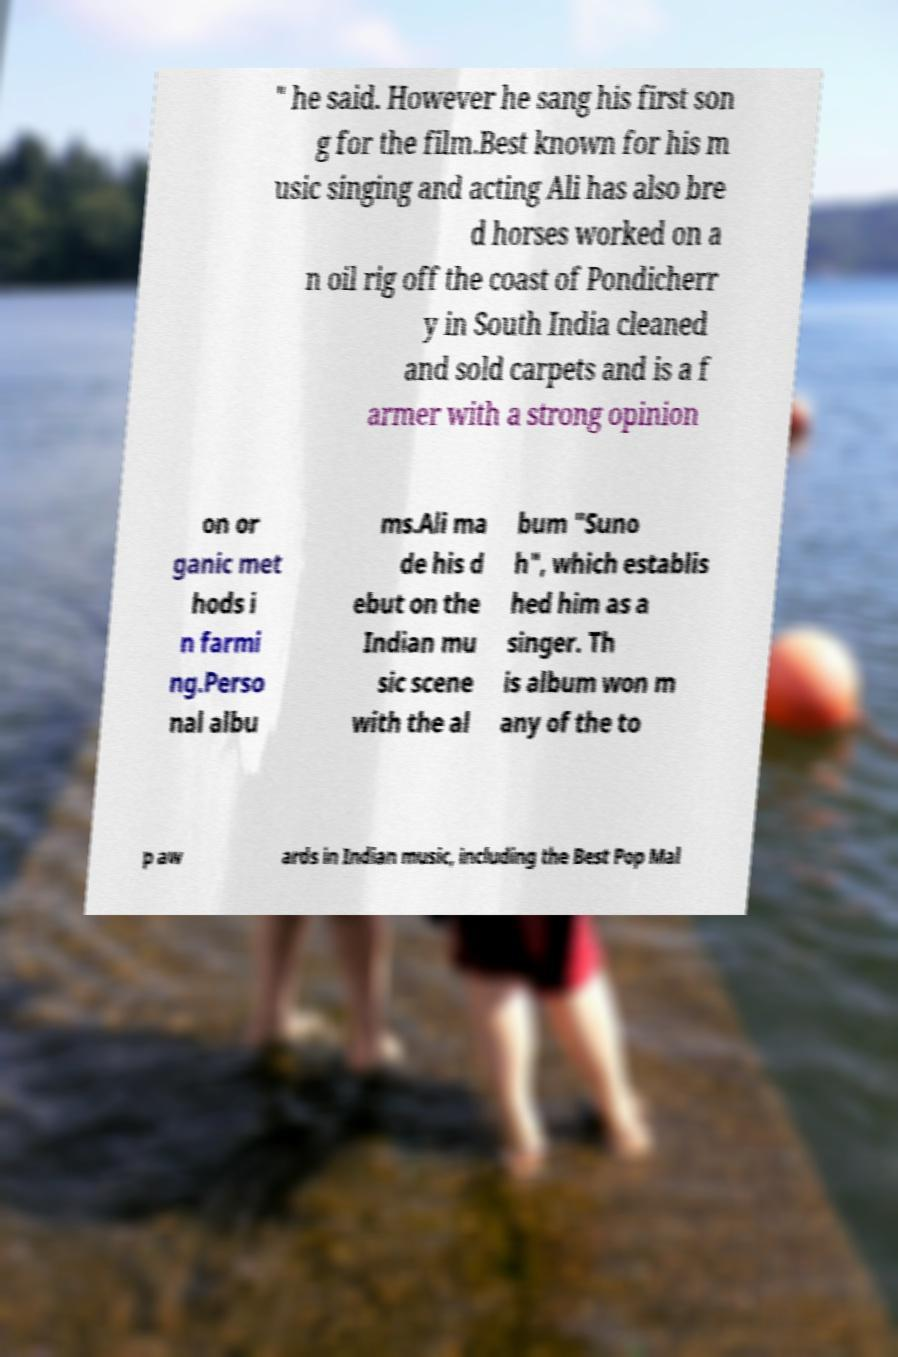Can you read and provide the text displayed in the image?This photo seems to have some interesting text. Can you extract and type it out for me? " he said. However he sang his first son g for the film.Best known for his m usic singing and acting Ali has also bre d horses worked on a n oil rig off the coast of Pondicherr y in South India cleaned and sold carpets and is a f armer with a strong opinion on or ganic met hods i n farmi ng.Perso nal albu ms.Ali ma de his d ebut on the Indian mu sic scene with the al bum "Suno h", which establis hed him as a singer. Th is album won m any of the to p aw ards in Indian music, including the Best Pop Mal 